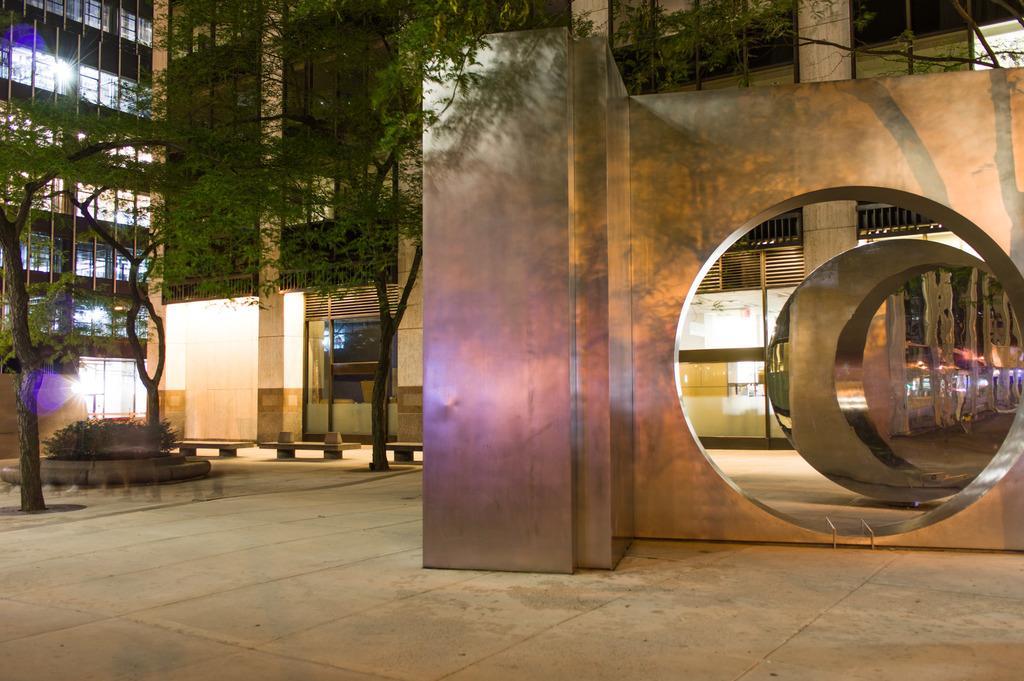Could you give a brief overview of what you see in this image? In this picture we can see an architecture. On the left side of the architecture, there are trees, plants and benches. Behind the trees, there are buildings. 